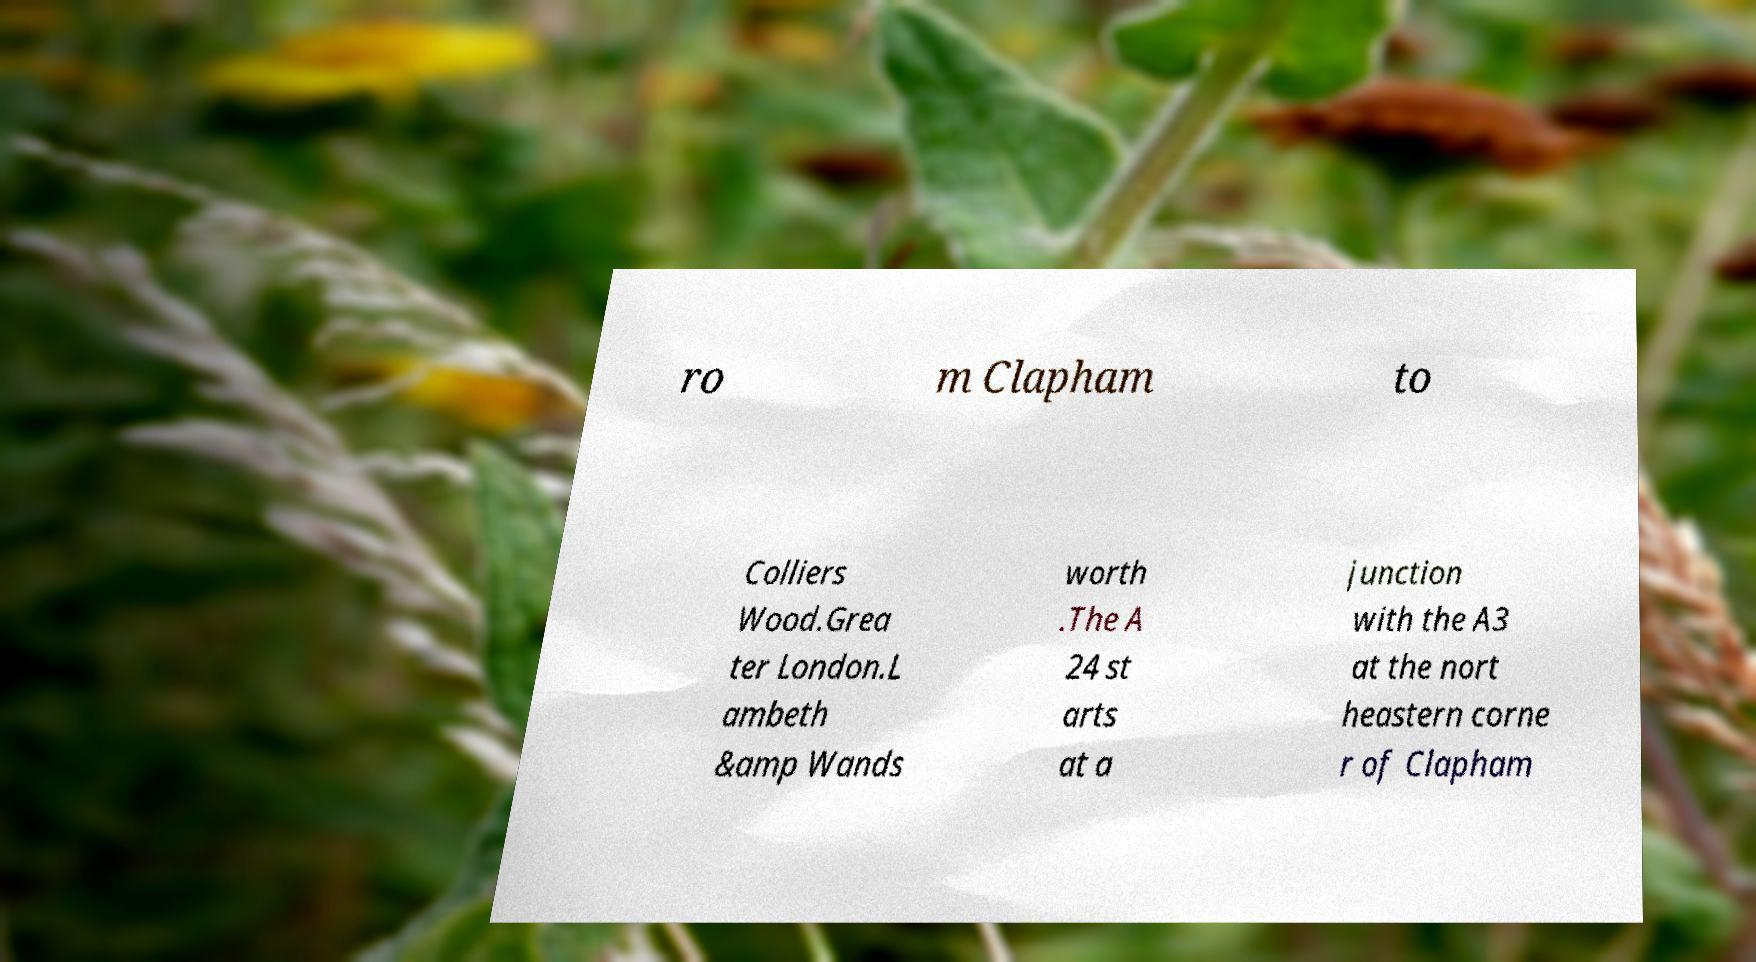Can you accurately transcribe the text from the provided image for me? ro m Clapham to Colliers Wood.Grea ter London.L ambeth &amp Wands worth .The A 24 st arts at a junction with the A3 at the nort heastern corne r of Clapham 